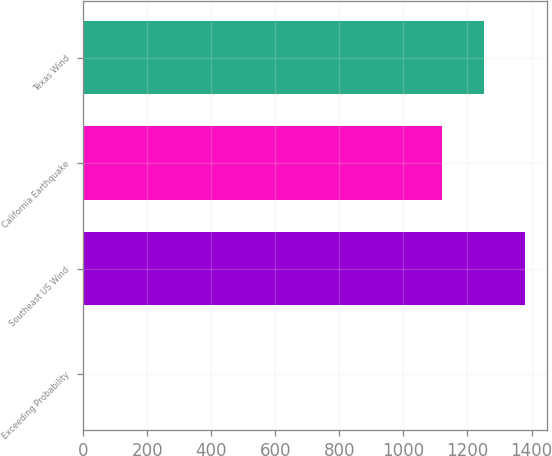<chart> <loc_0><loc_0><loc_500><loc_500><bar_chart><fcel>Exceeding Probability<fcel>Southeast US Wind<fcel>California Earthquake<fcel>Texas Wind<nl><fcel>0.4<fcel>1379.92<fcel>1121<fcel>1250.46<nl></chart> 